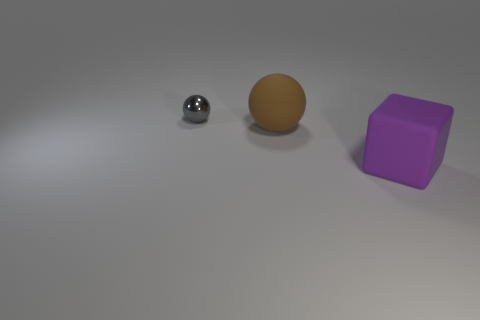There is a big rubber object behind the purple rubber block; is its shape the same as the matte thing that is to the right of the large brown rubber ball? no 